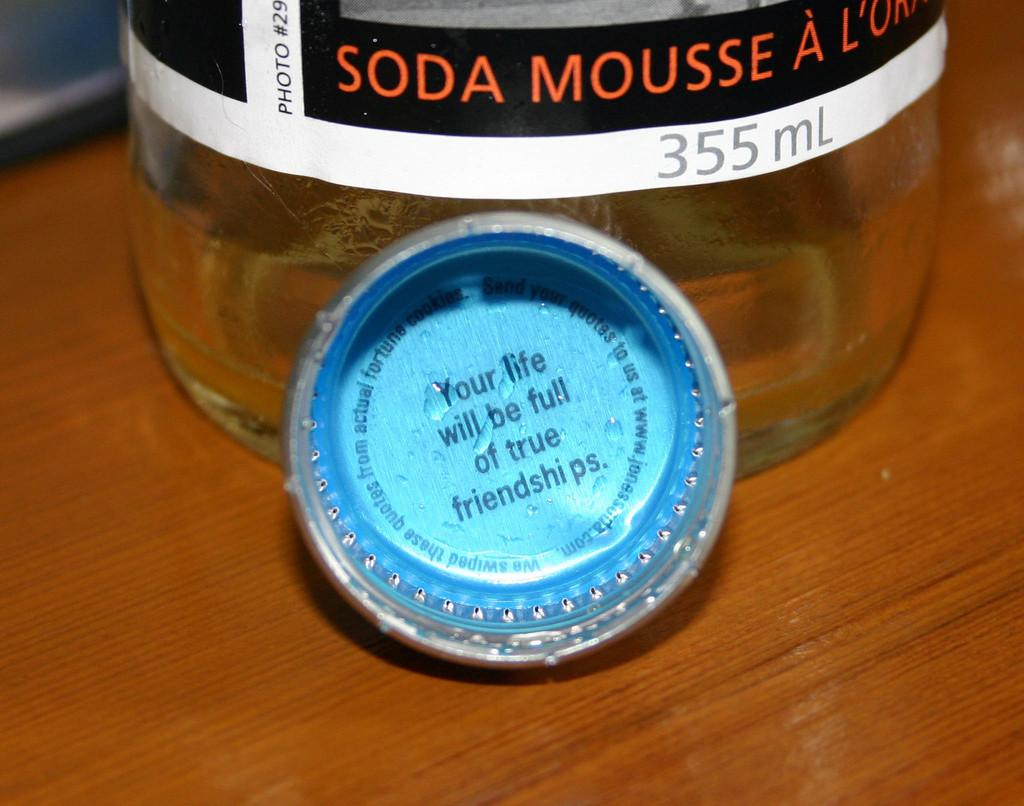<image>
Relay a brief, clear account of the picture shown. A bottle cap that says your life will be full of true friendships in in front of a soda mousse bottle. 